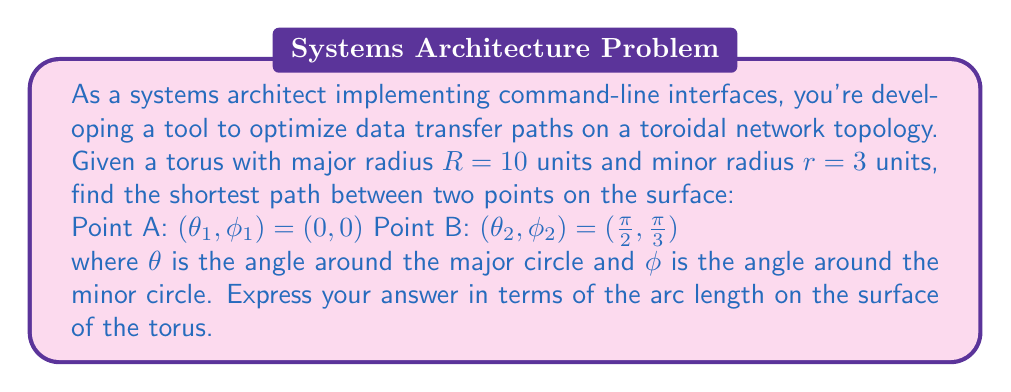Can you solve this math problem? To solve this problem, we'll follow these steps:

1) The distance between two points on a torus surface can be calculated using the geodesic distance formula:

   $$d = \sqrt{((R+r\cos\phi_2)\theta_2 - (R+r\cos\phi_1)\theta_1)^2 + r^2(\phi_2-\phi_1)^2}$$

2) We're given:
   $R = 10$, $r = 3$
   $(\theta_1, \phi_1) = (0, 0)$
   $(\theta_2, \phi_2) = (\frac{\pi}{2}, \frac{\pi}{3})$

3) Let's substitute these values into the formula:

   $$d = \sqrt{((10+3\cos\frac{\pi}{3})\frac{\pi}{2} - (10+3\cos0)0)^2 + 3^2(\frac{\pi}{3}-0)^2}$$

4) Simplify:
   $\cos\frac{\pi}{3} = \frac{1}{2}$, $\cos0 = 1$

   $$d = \sqrt{((10+3\cdot\frac{1}{2})\frac{\pi}{2})^2 + 3^2(\frac{\pi}{3})^2}$$

5) Calculate:

   $$d = \sqrt{((11.5)\frac{\pi}{2})^2 + 9(\frac{\pi}{3})^2}$$
   $$d = \sqrt{(18.0642)^2 + (3.1416)^2}$$
   $$d = \sqrt{326.3155 + 9.8696}$$
   $$d = \sqrt{336.1851}$$
   $$d \approx 18.3354$$

Therefore, the shortest path between the two points on the surface of the torus is approximately 18.3354 units.
Answer: The shortest path between the two points on the surface of the torus is approximately 18.3354 units. 